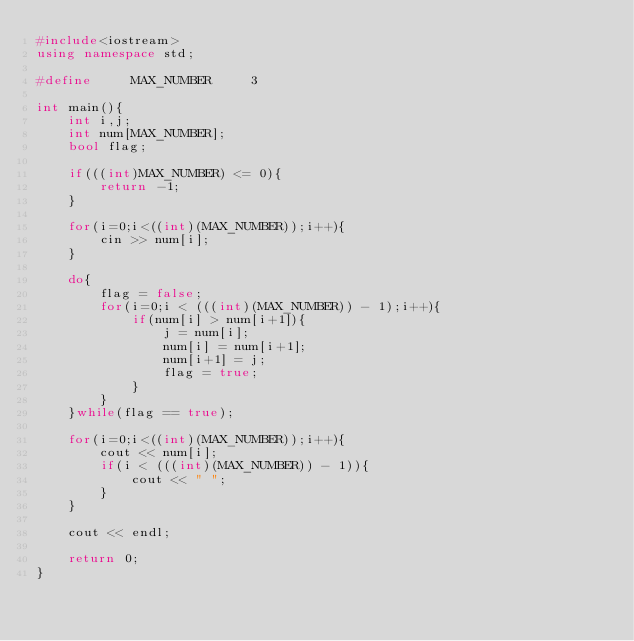<code> <loc_0><loc_0><loc_500><loc_500><_C++_>#include<iostream>
using namespace std;

#define     MAX_NUMBER     3

int main(){
	int i,j;
	int num[MAX_NUMBER];
	bool flag;

	if(((int)MAX_NUMBER) <= 0){
		return -1;
	}

	for(i=0;i<((int)(MAX_NUMBER));i++){
		cin >> num[i];
	}

	do{
		flag = false;
		for(i=0;i < (((int)(MAX_NUMBER)) - 1);i++){
			if(num[i] > num[i+1]){
				j = num[i];
				num[i] = num[i+1];
				num[i+1] = j;
				flag = true;
			}
		}
	}while(flag == true);

	for(i=0;i<((int)(MAX_NUMBER));i++){
		cout << num[i];
		if(i < (((int)(MAX_NUMBER)) - 1)){
			cout << " ";
		}
	}

	cout << endl;

	return 0;
}</code> 